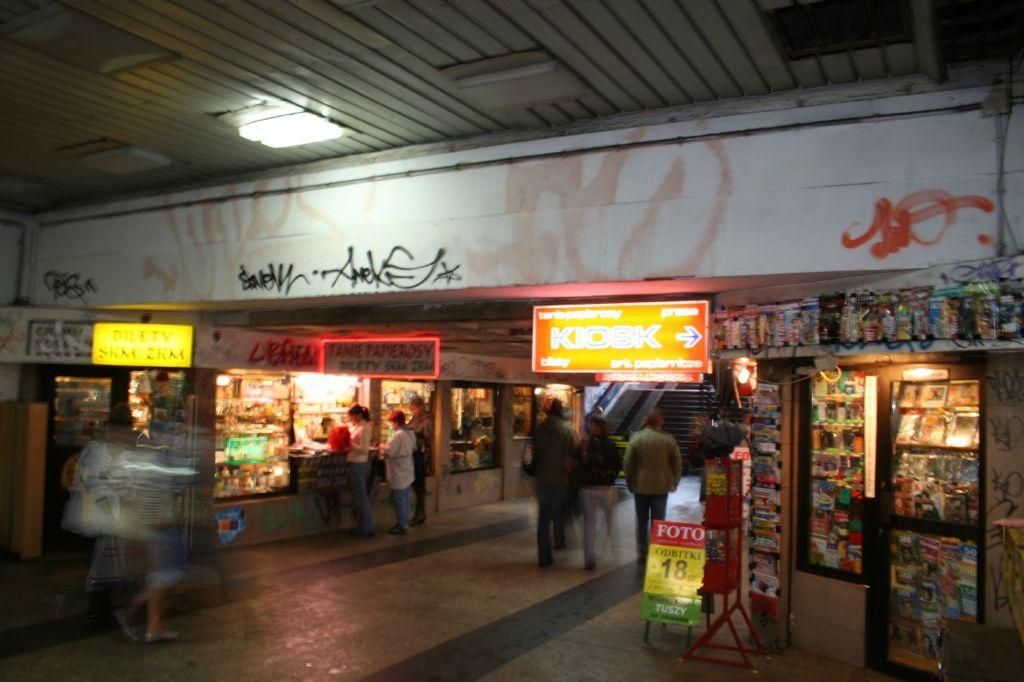<image>
Write a terse but informative summary of the picture. an underground building with a glowing sign saying the kiosk is to the right 